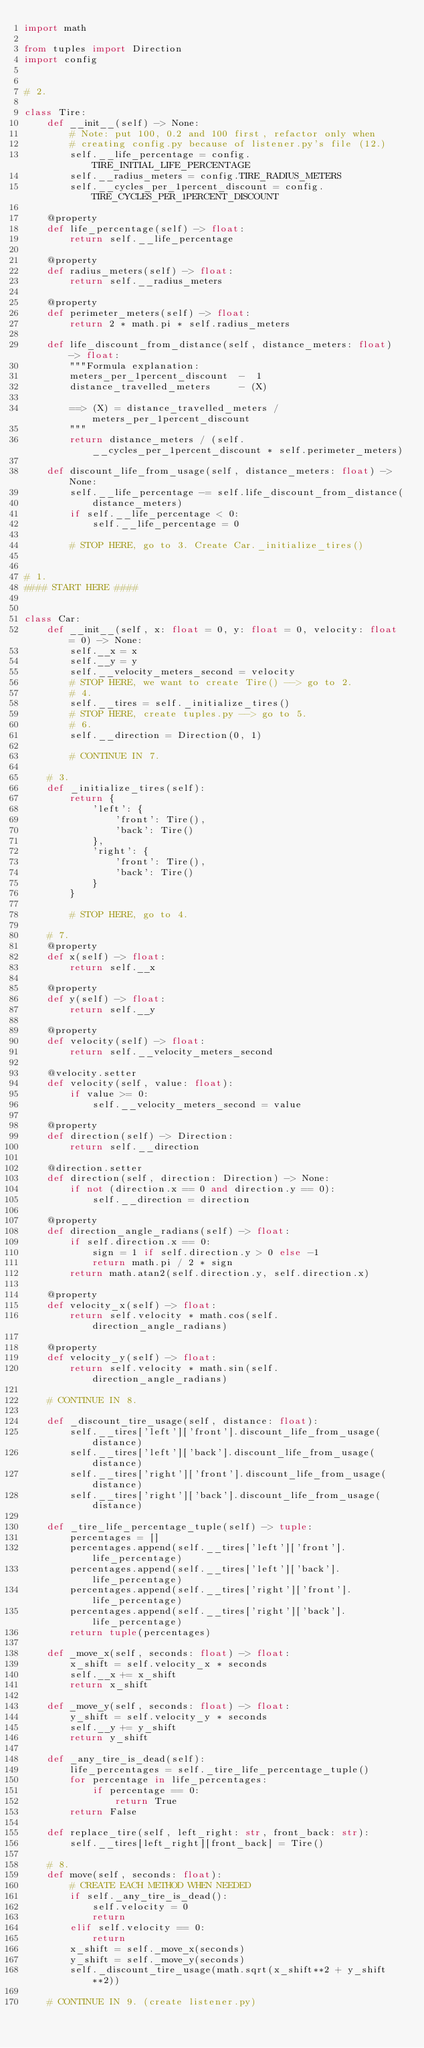<code> <loc_0><loc_0><loc_500><loc_500><_Python_>import math

from tuples import Direction
import config


# 2.

class Tire:
    def __init__(self) -> None:
        # Note: put 100, 0.2 and 100 first, refactor only when
        # creating config.py because of listener.py's file (12.)
        self.__life_percentage = config.TIRE_INITIAL_LIFE_PERCENTAGE
        self.__radius_meters = config.TIRE_RADIUS_METERS
        self.__cycles_per_1percent_discount = config.TIRE_CYCLES_PER_1PERCENT_DISCOUNT

    @property
    def life_percentage(self) -> float:
        return self.__life_percentage

    @property
    def radius_meters(self) -> float:
        return self.__radius_meters

    @property
    def perimeter_meters(self) -> float:
        return 2 * math.pi * self.radius_meters

    def life_discount_from_distance(self, distance_meters: float) -> float:
        """Formula explanation:
        meters_per_1percent_discount  -  1
        distance_travelled_meters     - (X)

        ==> (X) = distance_travelled_meters / meters_per_1percent_discount
        """
        return distance_meters / (self.__cycles_per_1percent_discount * self.perimeter_meters)

    def discount_life_from_usage(self, distance_meters: float) -> None:
        self.__life_percentage -= self.life_discount_from_distance(
            distance_meters)
        if self.__life_percentage < 0:
            self.__life_percentage = 0

        # STOP HERE, go to 3. Create Car._initialize_tires()


# 1.
#### START HERE ####


class Car:
    def __init__(self, x: float = 0, y: float = 0, velocity: float = 0) -> None:
        self.__x = x
        self.__y = y
        self.__velocity_meters_second = velocity
        # STOP HERE, we want to create Tire() --> go to 2.
        # 4.
        self.__tires = self._initialize_tires()
        # STOP HERE, create tuples.py --> go to 5.
        # 6.
        self.__direction = Direction(0, 1)

        # CONTINUE IN 7.

    # 3.
    def _initialize_tires(self):
        return {
            'left': {
                'front': Tire(),
                'back': Tire()
            },
            'right': {
                'front': Tire(),
                'back': Tire()
            }
        }

        # STOP HERE, go to 4.

    # 7.
    @property
    def x(self) -> float:
        return self.__x

    @property
    def y(self) -> float:
        return self.__y

    @property
    def velocity(self) -> float:
        return self.__velocity_meters_second

    @velocity.setter
    def velocity(self, value: float):
        if value >= 0:
            self.__velocity_meters_second = value

    @property
    def direction(self) -> Direction:
        return self.__direction

    @direction.setter
    def direction(self, direction: Direction) -> None:
        if not (direction.x == 0 and direction.y == 0):
            self.__direction = direction

    @property
    def direction_angle_radians(self) -> float:
        if self.direction.x == 0:
            sign = 1 if self.direction.y > 0 else -1
            return math.pi / 2 * sign
        return math.atan2(self.direction.y, self.direction.x)

    @property
    def velocity_x(self) -> float:
        return self.velocity * math.cos(self.direction_angle_radians)

    @property
    def velocity_y(self) -> float:
        return self.velocity * math.sin(self.direction_angle_radians)

    # CONTINUE IN 8.

    def _discount_tire_usage(self, distance: float):
        self.__tires['left']['front'].discount_life_from_usage(distance)
        self.__tires['left']['back'].discount_life_from_usage(distance)
        self.__tires['right']['front'].discount_life_from_usage(distance)
        self.__tires['right']['back'].discount_life_from_usage(distance)

    def _tire_life_percentage_tuple(self) -> tuple:
        percentages = []
        percentages.append(self.__tires['left']['front'].life_percentage)
        percentages.append(self.__tires['left']['back'].life_percentage)
        percentages.append(self.__tires['right']['front'].life_percentage)
        percentages.append(self.__tires['right']['back'].life_percentage)
        return tuple(percentages)

    def _move_x(self, seconds: float) -> float:
        x_shift = self.velocity_x * seconds
        self.__x += x_shift
        return x_shift

    def _move_y(self, seconds: float) -> float:
        y_shift = self.velocity_y * seconds
        self.__y += y_shift
        return y_shift

    def _any_tire_is_dead(self):
        life_percentages = self._tire_life_percentage_tuple()
        for percentage in life_percentages:
            if percentage == 0:
                return True
        return False

    def replace_tire(self, left_right: str, front_back: str):
        self.__tires[left_right][front_back] = Tire()

    # 8.
    def move(self, seconds: float):
        # CREATE EACH METHOD WHEN NEEDED
        if self._any_tire_is_dead():
            self.velocity = 0
            return
        elif self.velocity == 0:
            return
        x_shift = self._move_x(seconds)
        y_shift = self._move_y(seconds)
        self._discount_tire_usage(math.sqrt(x_shift**2 + y_shift**2))

    # CONTINUE IN 9. (create listener.py)
</code> 